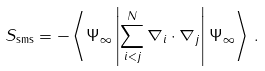<formula> <loc_0><loc_0><loc_500><loc_500>S _ { \text {{sms}} } = - \left \langle \Psi _ { \infty } \left | \sum _ { i < j } ^ { N } \nabla _ { i } \cdot \nabla _ { j } \right | \Psi _ { \infty } \right \rangle \, .</formula> 